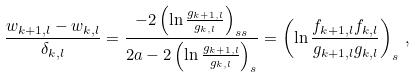<formula> <loc_0><loc_0><loc_500><loc_500>\frac { w _ { k + 1 , l } - w _ { k , l } } { \delta _ { k , l } } = \frac { - 2 \left ( \ln \frac { { g } _ { k + 1 , l } } { { g } _ { k , l } } \right ) _ { s s } } { 2 a - 2 \left ( \ln \frac { { g } _ { k + 1 , l } } { { g } _ { k , l } } \right ) _ { s } } = \left ( \ln \frac { f _ { k + 1 , l } f _ { k , l } } { { g } _ { k + 1 , l } { g } _ { k , l } } \right ) _ { s } \, ,</formula> 